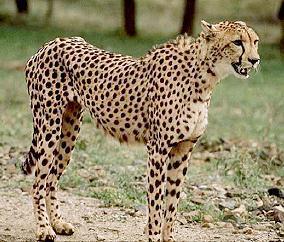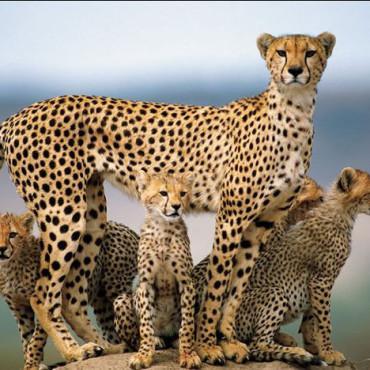The first image is the image on the left, the second image is the image on the right. Evaluate the accuracy of this statement regarding the images: "There are 5 or more cheetahs.". Is it true? Answer yes or no. Yes. The first image is the image on the left, the second image is the image on the right. Analyze the images presented: Is the assertion "There are at least two leopards laying down on their sides together in one of the images." valid? Answer yes or no. No. 